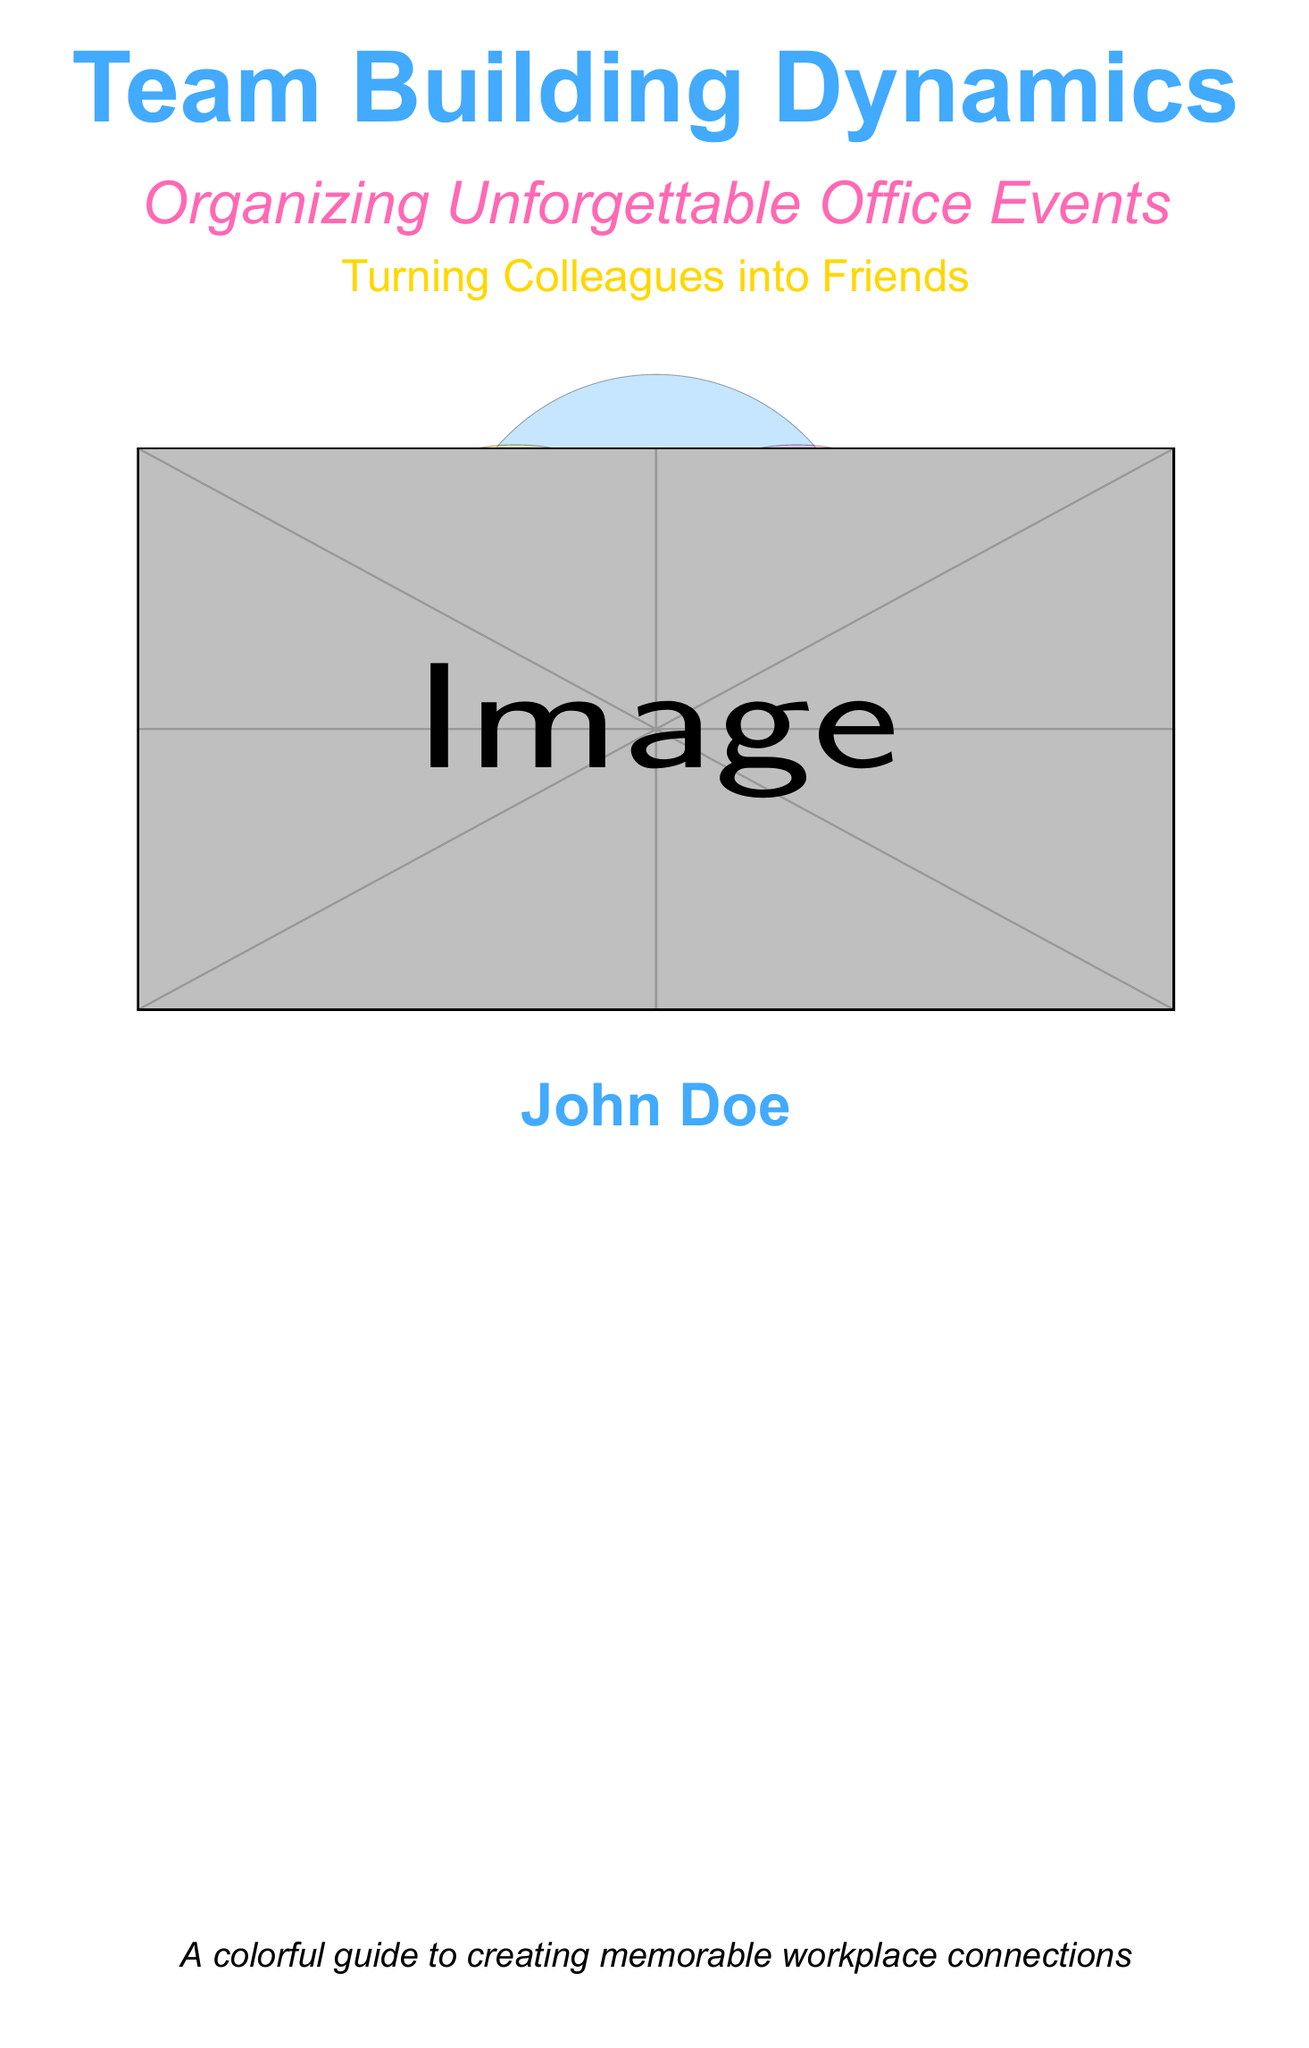What is the title of the book? The title is prominently displayed at the top of the book cover.
Answer: Team Building Dynamics What is the subtitle of the book? The subtitle is located below the main title and provides further context.
Answer: Organizing Unforgettable Office Events Who is the author of the book? The author's name is clearly listed at the bottom of the cover.
Answer: John Doe What theme is depicted in the cover design? The colors and images suggest a fun and festive atmosphere associated with office events.
Answer: Celebration What does the tagline emphasize? The tagline highlights the personal connections forged through team-building activities.
Answer: Turning Colleagues into Friends What colors are primarily used in the design? The cover showcases a combination of several bright colors, enhancing its festive look.
Answer: Blue, pink, yellow What type of events does the book focus on? The book's theme revolves around social interactions among coworkers.
Answer: Office events What type of imagery is used on the cover? The visuals include playful elements typical of celebrations, contributing to its engaging design.
Answer: Balloons and confetti 